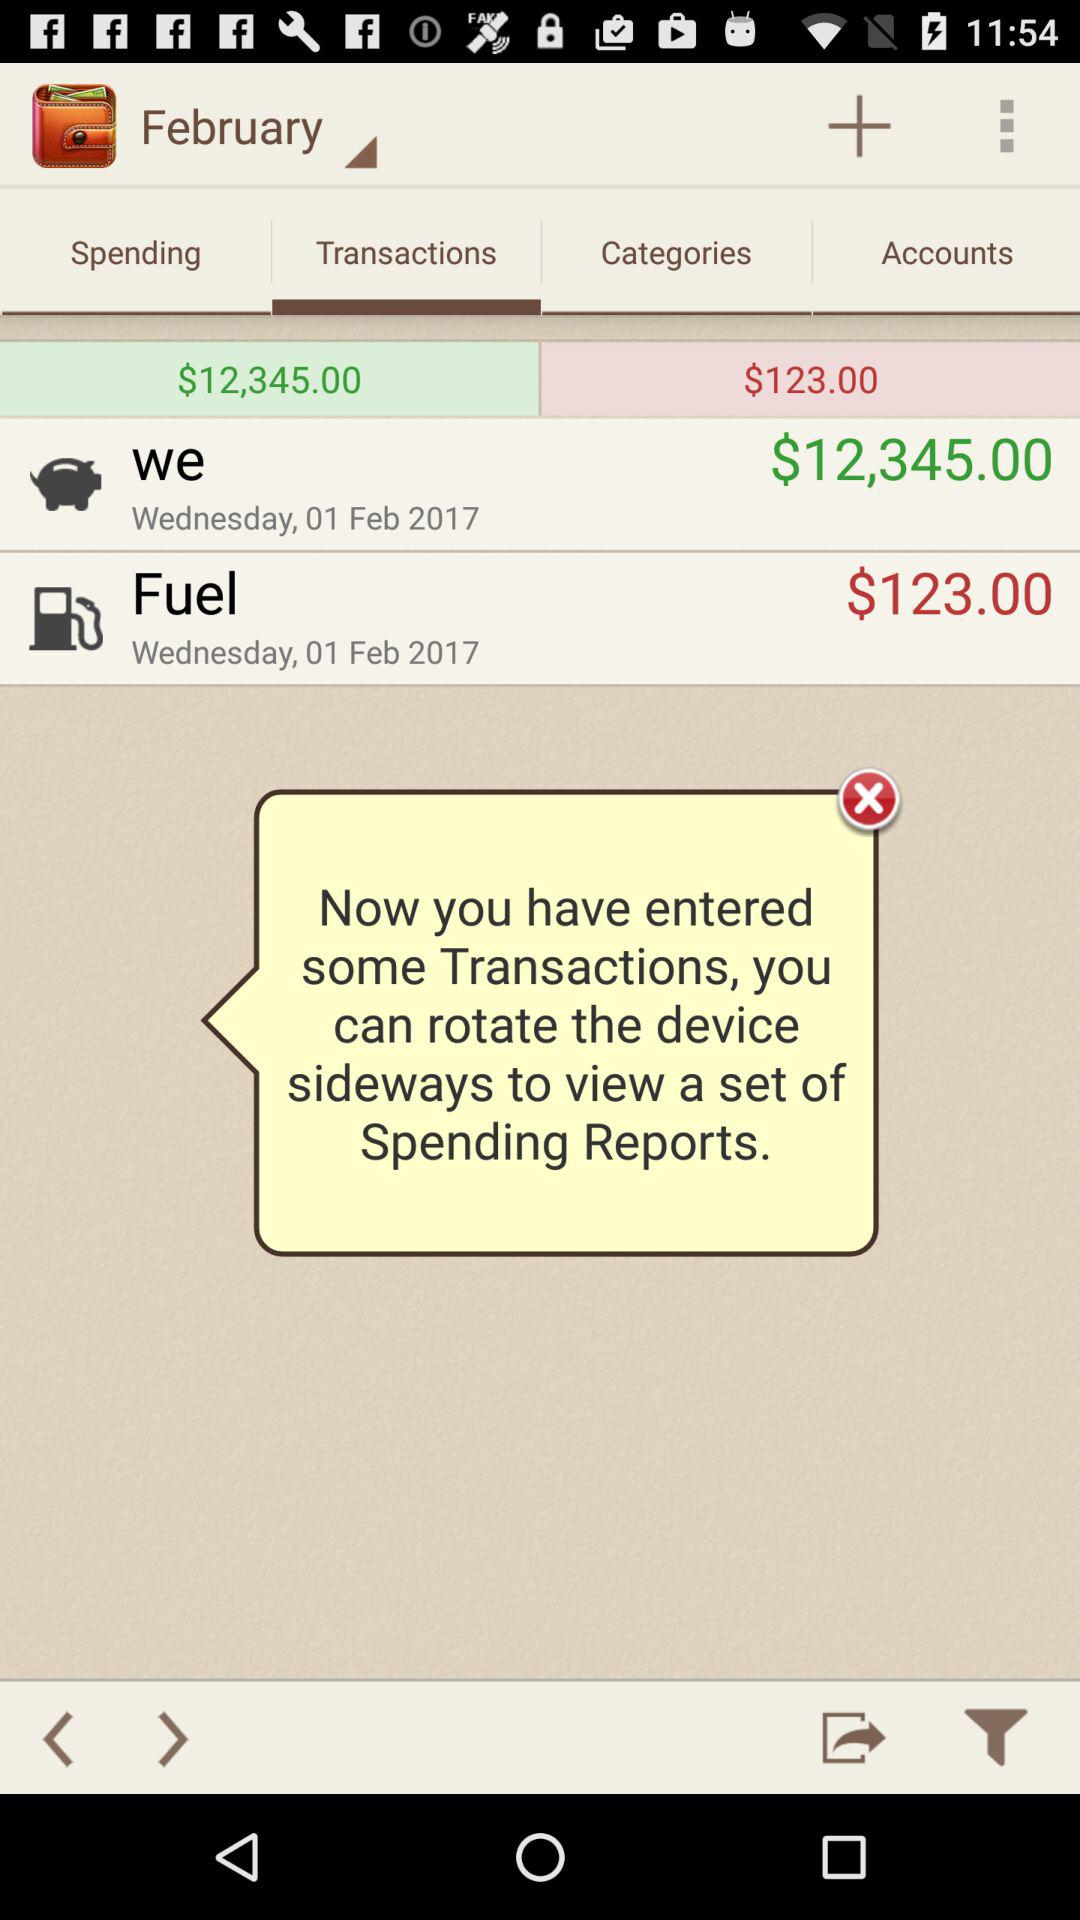How much were we charged for the fuel? You were charged $123.00 for the fuel. 